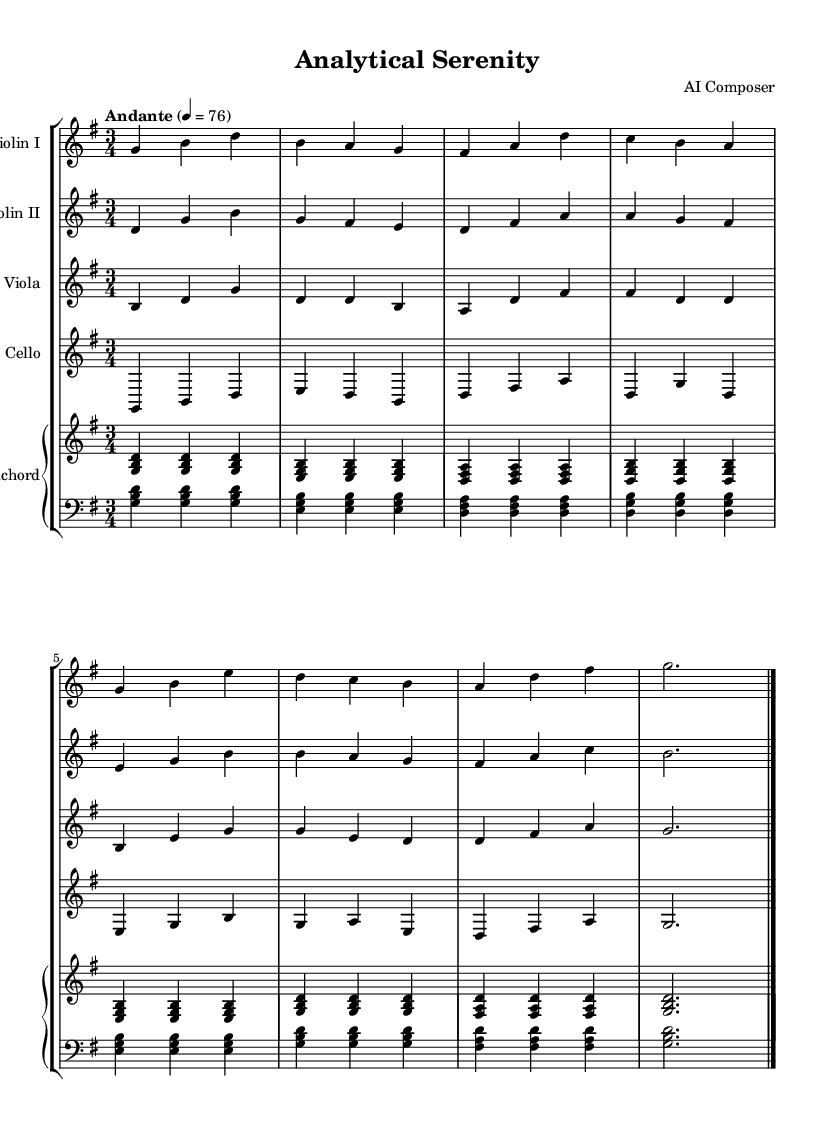What is the key signature of this music? The key signature is G major, which has one sharp (F#). This can be determined by looking at the key signature symbol at the beginning of the score that indicates G major.
Answer: G major What is the time signature? The time signature is 3/4, as indicated at the beginning of the music score. This means there are three beats in each measure and the quarter note gets one beat.
Answer: 3/4 What is the tempo marking of the piece? The tempo marking is "Andante," which refers to a moderately slow pace. The number "4 = 76" indicates that there are 76 beats per minute, giving further clarification about the speed.
Answer: Andante How many instruments are in this chamber music? There are five instruments: two violins, one viola, one cello, and one harpsichord. This can be counted by looking at the notation for each staff in the score.
Answer: Five What is the last note for the harpsichord? The last note for the harpsichord is G, indicated at the end of the score where the last note is placed on the staff. This is confirmed by identifying the final chord in the harpsichord line.
Answer: G What is the overall mood conveyed by this piece? The overall mood is calming, which can be inferred from the slow tempo (Andante), the 3/4 time signature, and the smooth melodic lines typically found in Baroque chamber music aimed at facilitating focus.
Answer: Calming 